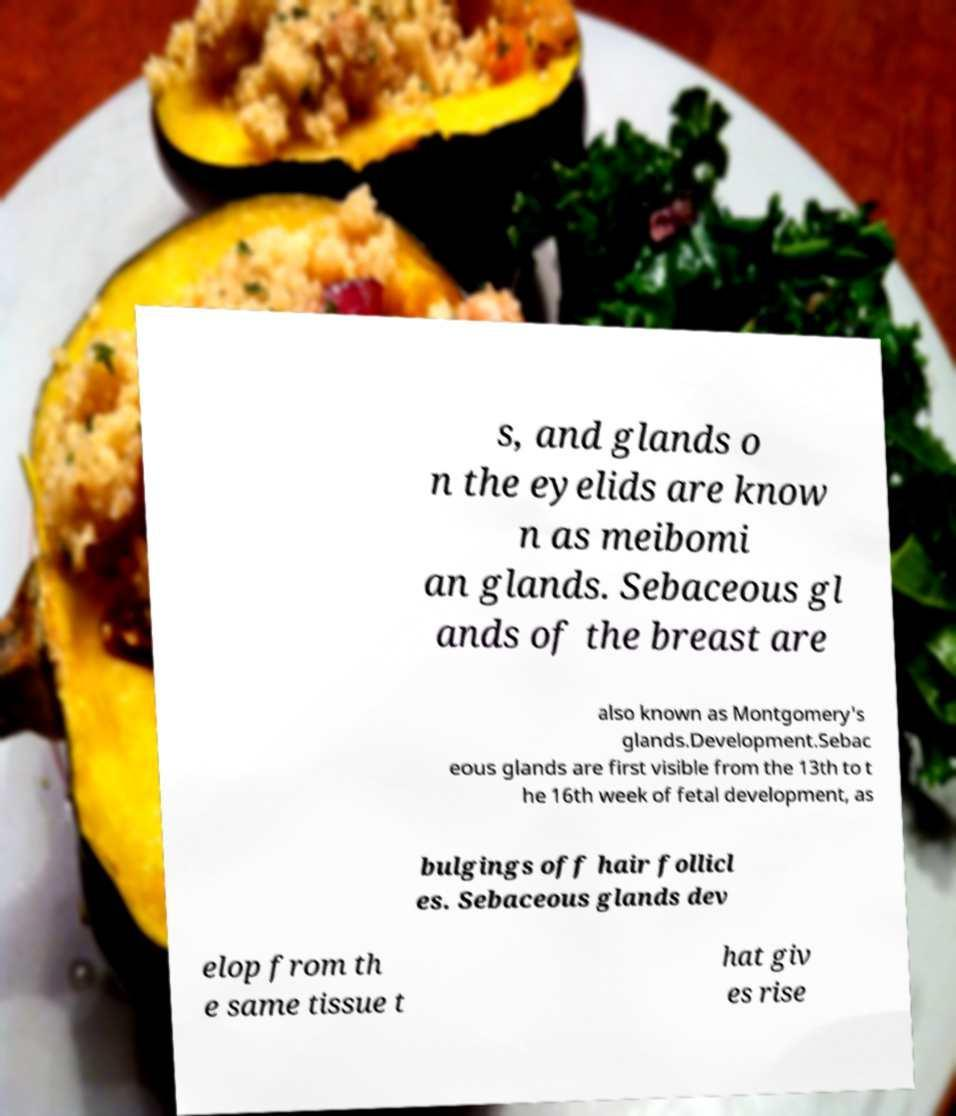Could you assist in decoding the text presented in this image and type it out clearly? s, and glands o n the eyelids are know n as meibomi an glands. Sebaceous gl ands of the breast are also known as Montgomery's glands.Development.Sebac eous glands are first visible from the 13th to t he 16th week of fetal development, as bulgings off hair follicl es. Sebaceous glands dev elop from th e same tissue t hat giv es rise 